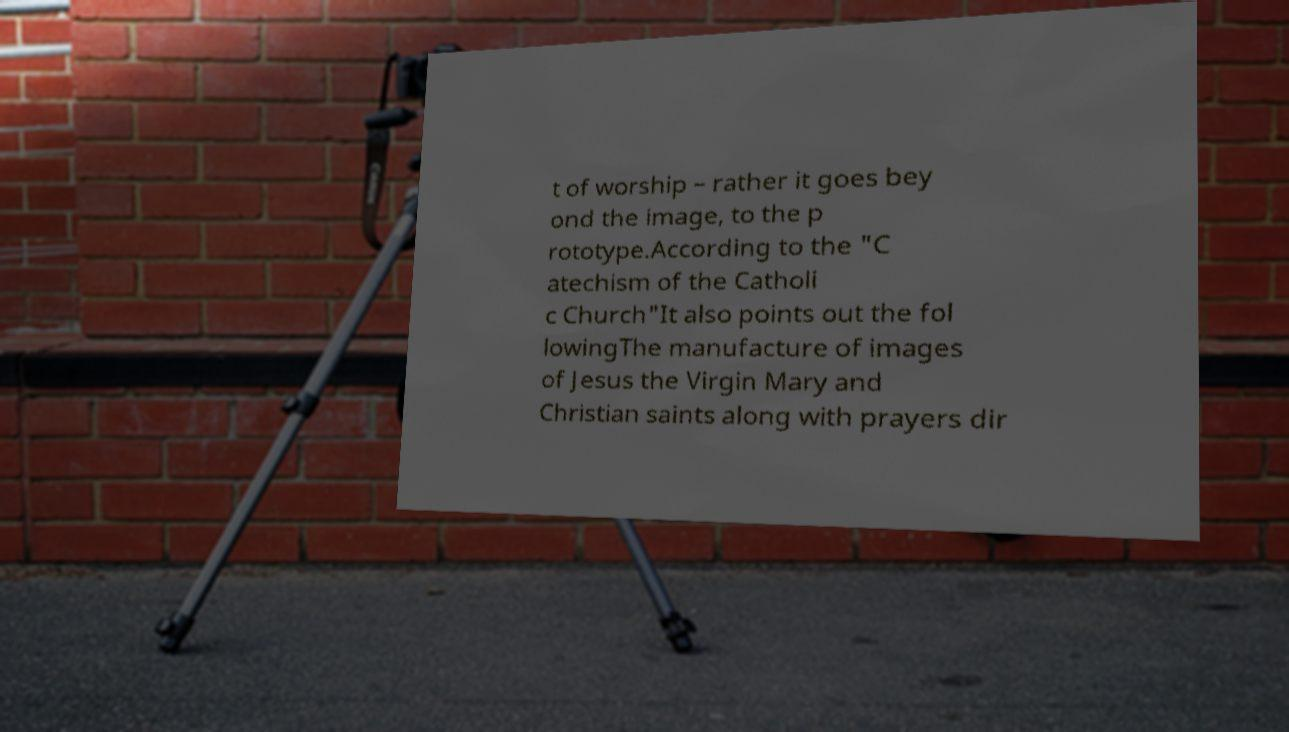I need the written content from this picture converted into text. Can you do that? t of worship – rather it goes bey ond the image, to the p rototype.According to the "C atechism of the Catholi c Church"It also points out the fol lowingThe manufacture of images of Jesus the Virgin Mary and Christian saints along with prayers dir 